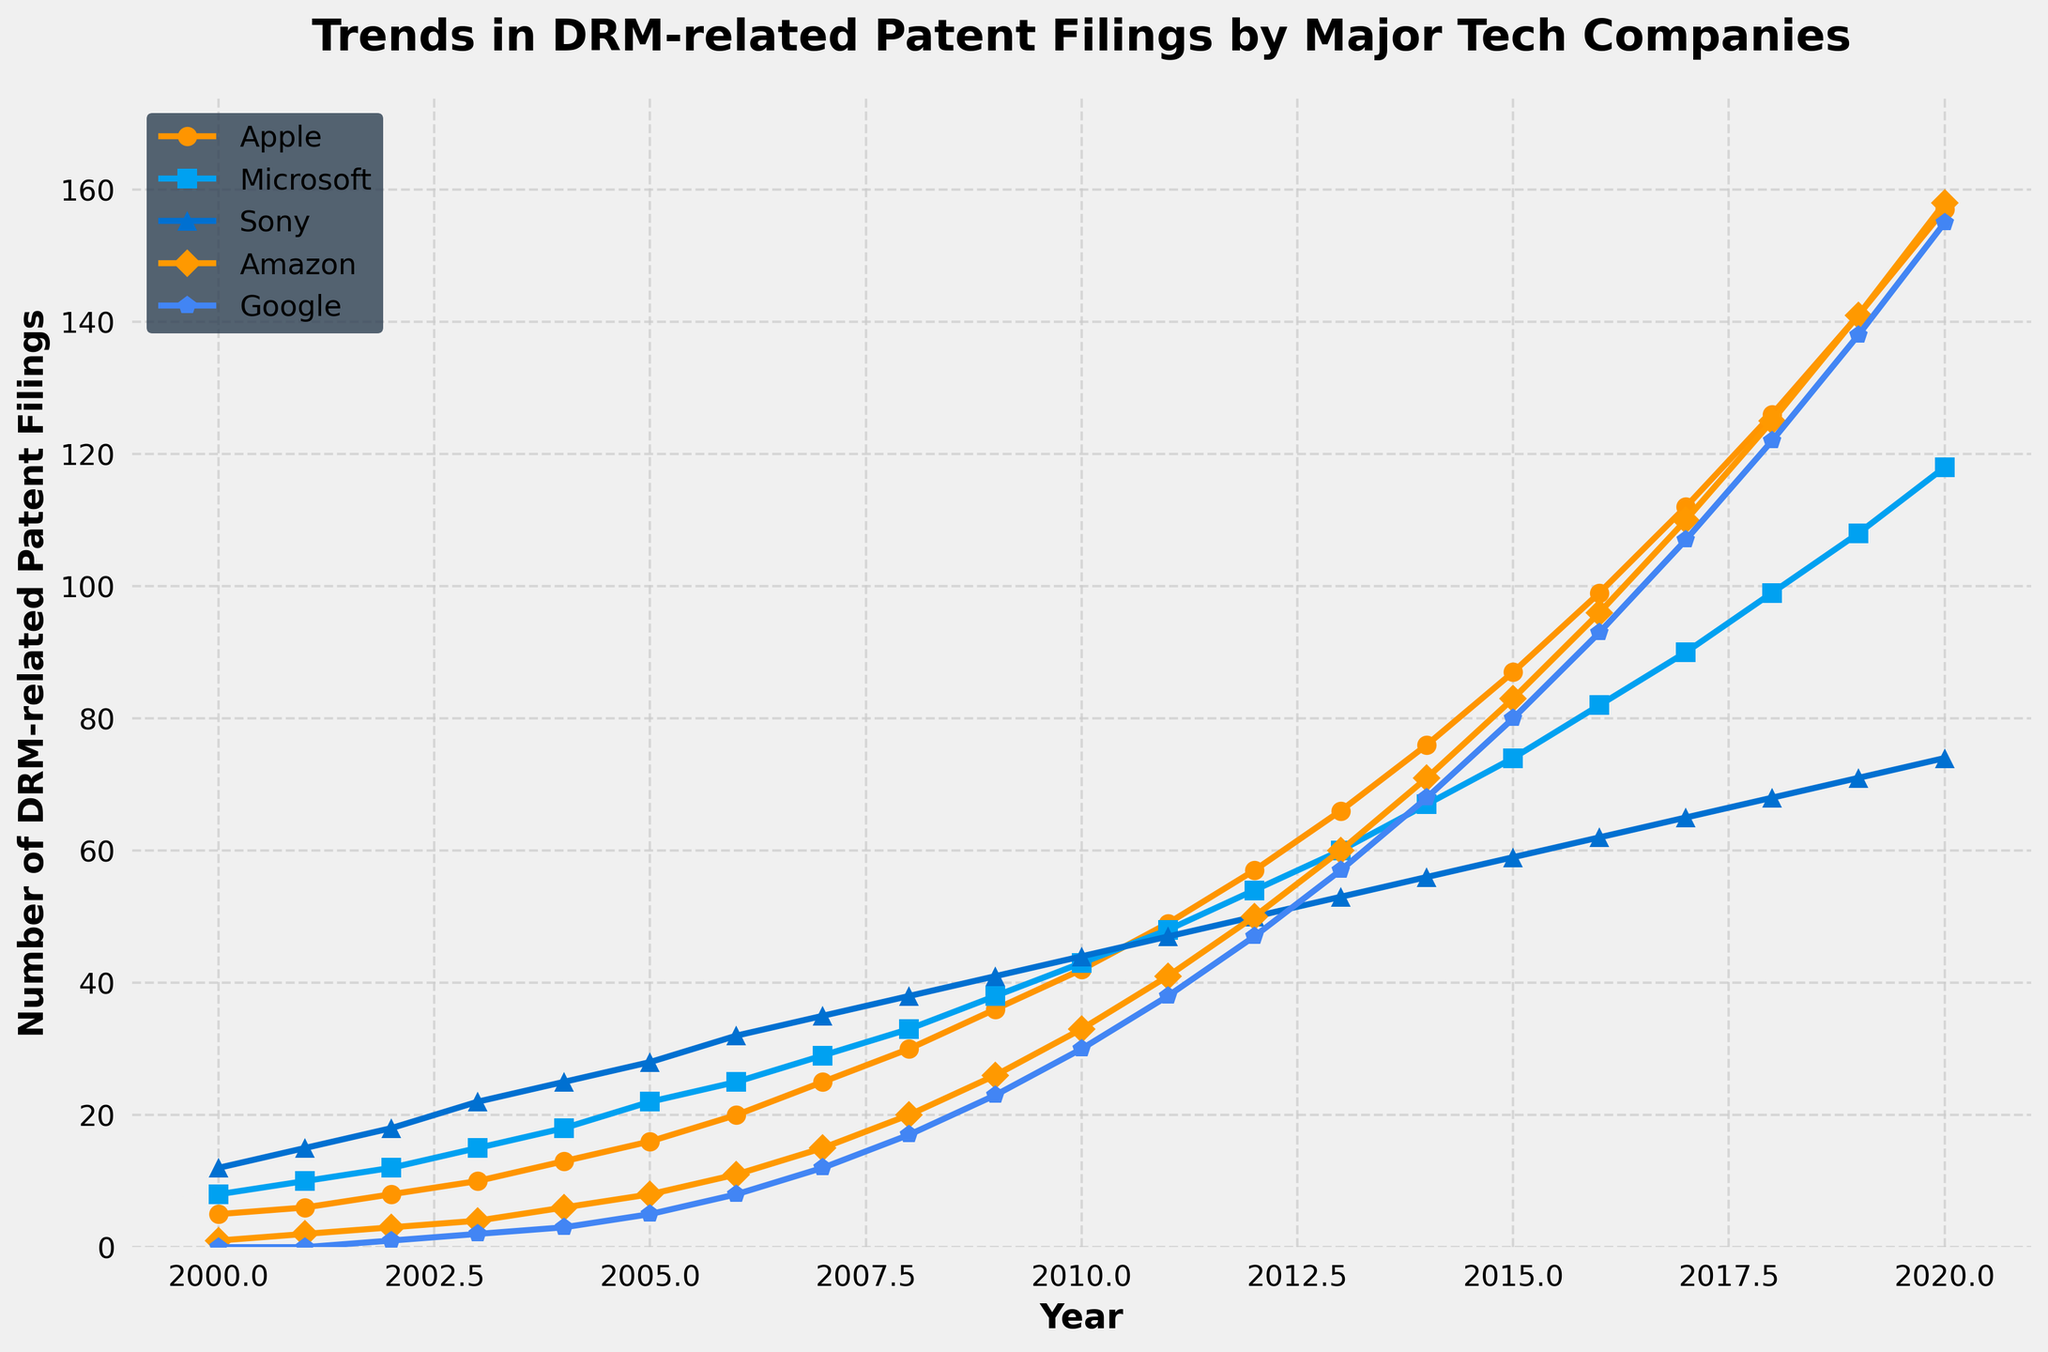Which company had the highest number of DRM-related patent filings in 2020? Look at the endpoints of the lines in 2020 on the right side of the graph. Apple has the highest value compared to the others.
Answer: Apple What is the total number of DRM-related patent filings for Microsoft and Google in 2015? Find the values for Microsoft and Google for the year 2015 (74 and 80, respectively) and add them together. The sum is 74 + 80 = 154.
Answer: 154 In which year did Amazon overtake Sony in DRM-related patent filings? Observe the two lines representing Amazon and Sony. Check the year where Amazon's line first surpasses Sony's line. This occurs in 2012.
Answer: 2012 Which company experienced the steepest increase in DRM-related patent filings between 2017 and 2018? Compare the increments from 2017 to 2018 for all companies: Apple (126-112=14), Microsoft (99-90=9), Sony (68-65=3), Amazon (125-110=15), and Google (122-107=15). Amazon and Google both had the steepest increase of 15 filings.
Answer: Amazon and Google What was the difference in the number of DRM-related patent filings between Apple and Sony in 2009? Find the values for Apple and Sony in 2009 (36 and 41, respectively) and calculate the difference. The difference is 41 - 36 = 5.
Answer: 5 Which year saw the maximum number of DRM-related patent filings for Amazon? Follow the line representing Amazon to identify the year with the highest endpoint value, which is 2020 with 158 filings.
Answer: 2020 By how much did the number of DRM-related patent filings for Google increase from 2010 to 2020? Look at the values for Google in 2010 and 2020 (30 and 155, respectively) and calculate the increase. The increase is 155 - 30 = 125.
Answer: 125 Compare the trends for Microsoft and Sony and determine when their trends deviated the most. Observe the overall trendlines for Microsoft and Sony and identify where the gap between them is the widest. The largest deviation appears after 2012.
Answer: After 2012 Which company showed the most consistent growth in DRM-related patent filings over the past two decades? Examine the linearity and smoothness of the growth for each company. Apple's line shows a steady and consistent growth trend over the years.
Answer: Apple Calculate the average annual DRM-related patent filings for Sony between 2000 and 2020. Sum the number of filings for Sony from 2000 to 2020 and divide by the number of years (21 years). The total is (12 + 15 + ... + 71 + 74). The calculation yields an average of approximately 47.95.
Answer: 47.95 